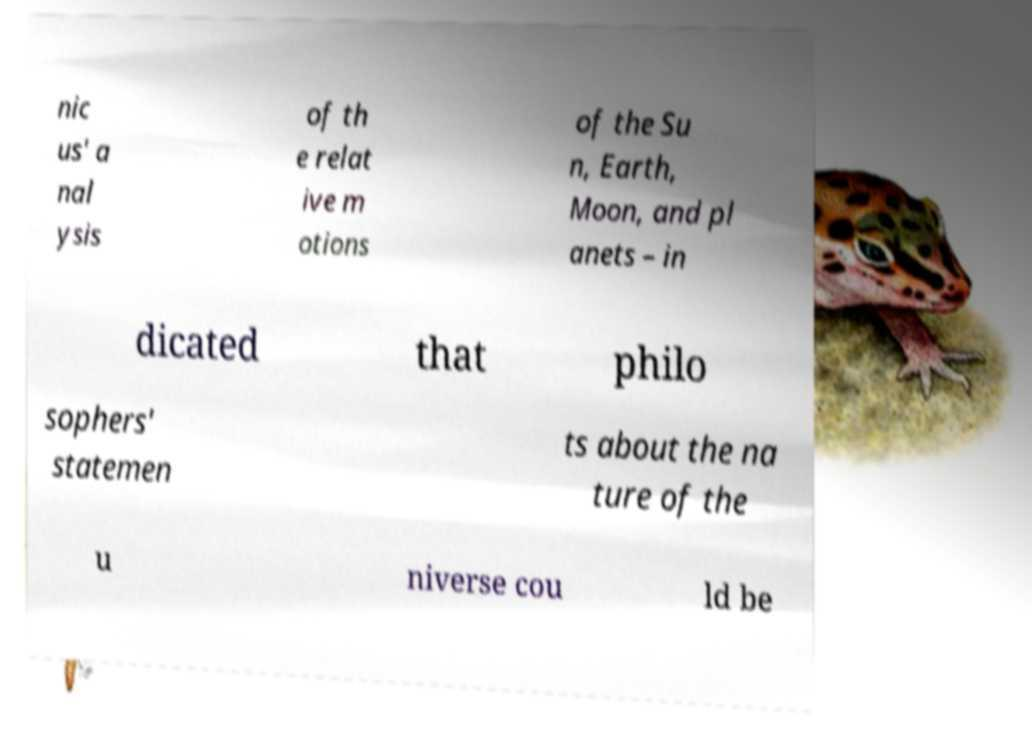I need the written content from this picture converted into text. Can you do that? nic us' a nal ysis of th e relat ive m otions of the Su n, Earth, Moon, and pl anets – in dicated that philo sophers' statemen ts about the na ture of the u niverse cou ld be 